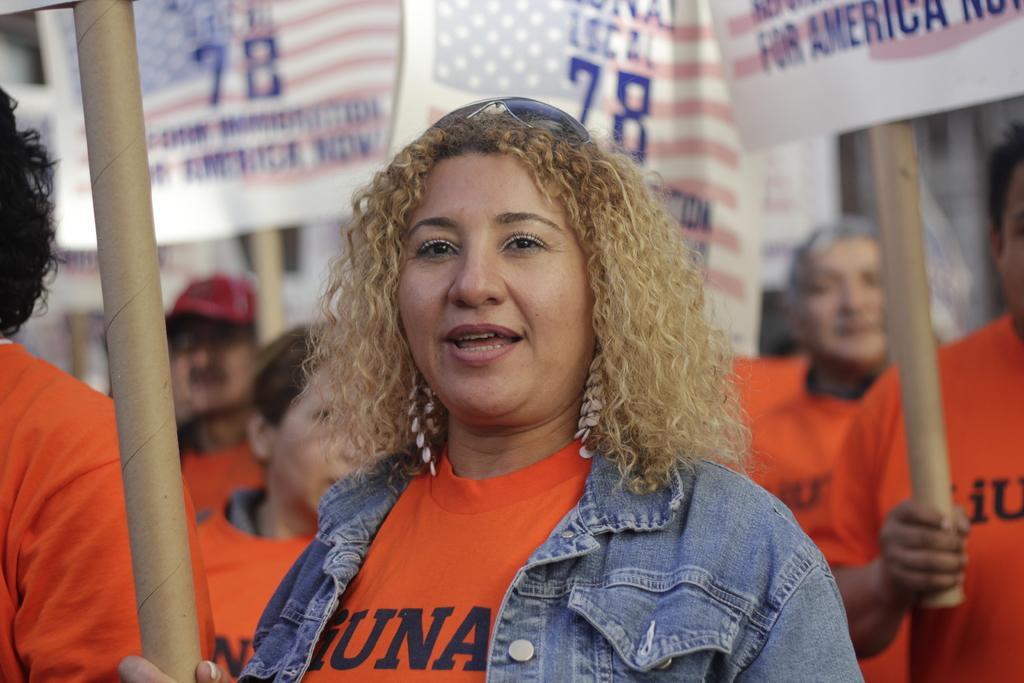Please provide a concise description of this image. In this image I can see the group of people with orange and blue color dresses. I can see these people are holding the banners. I can see one person wearing the cap and an another person with the goggles. 